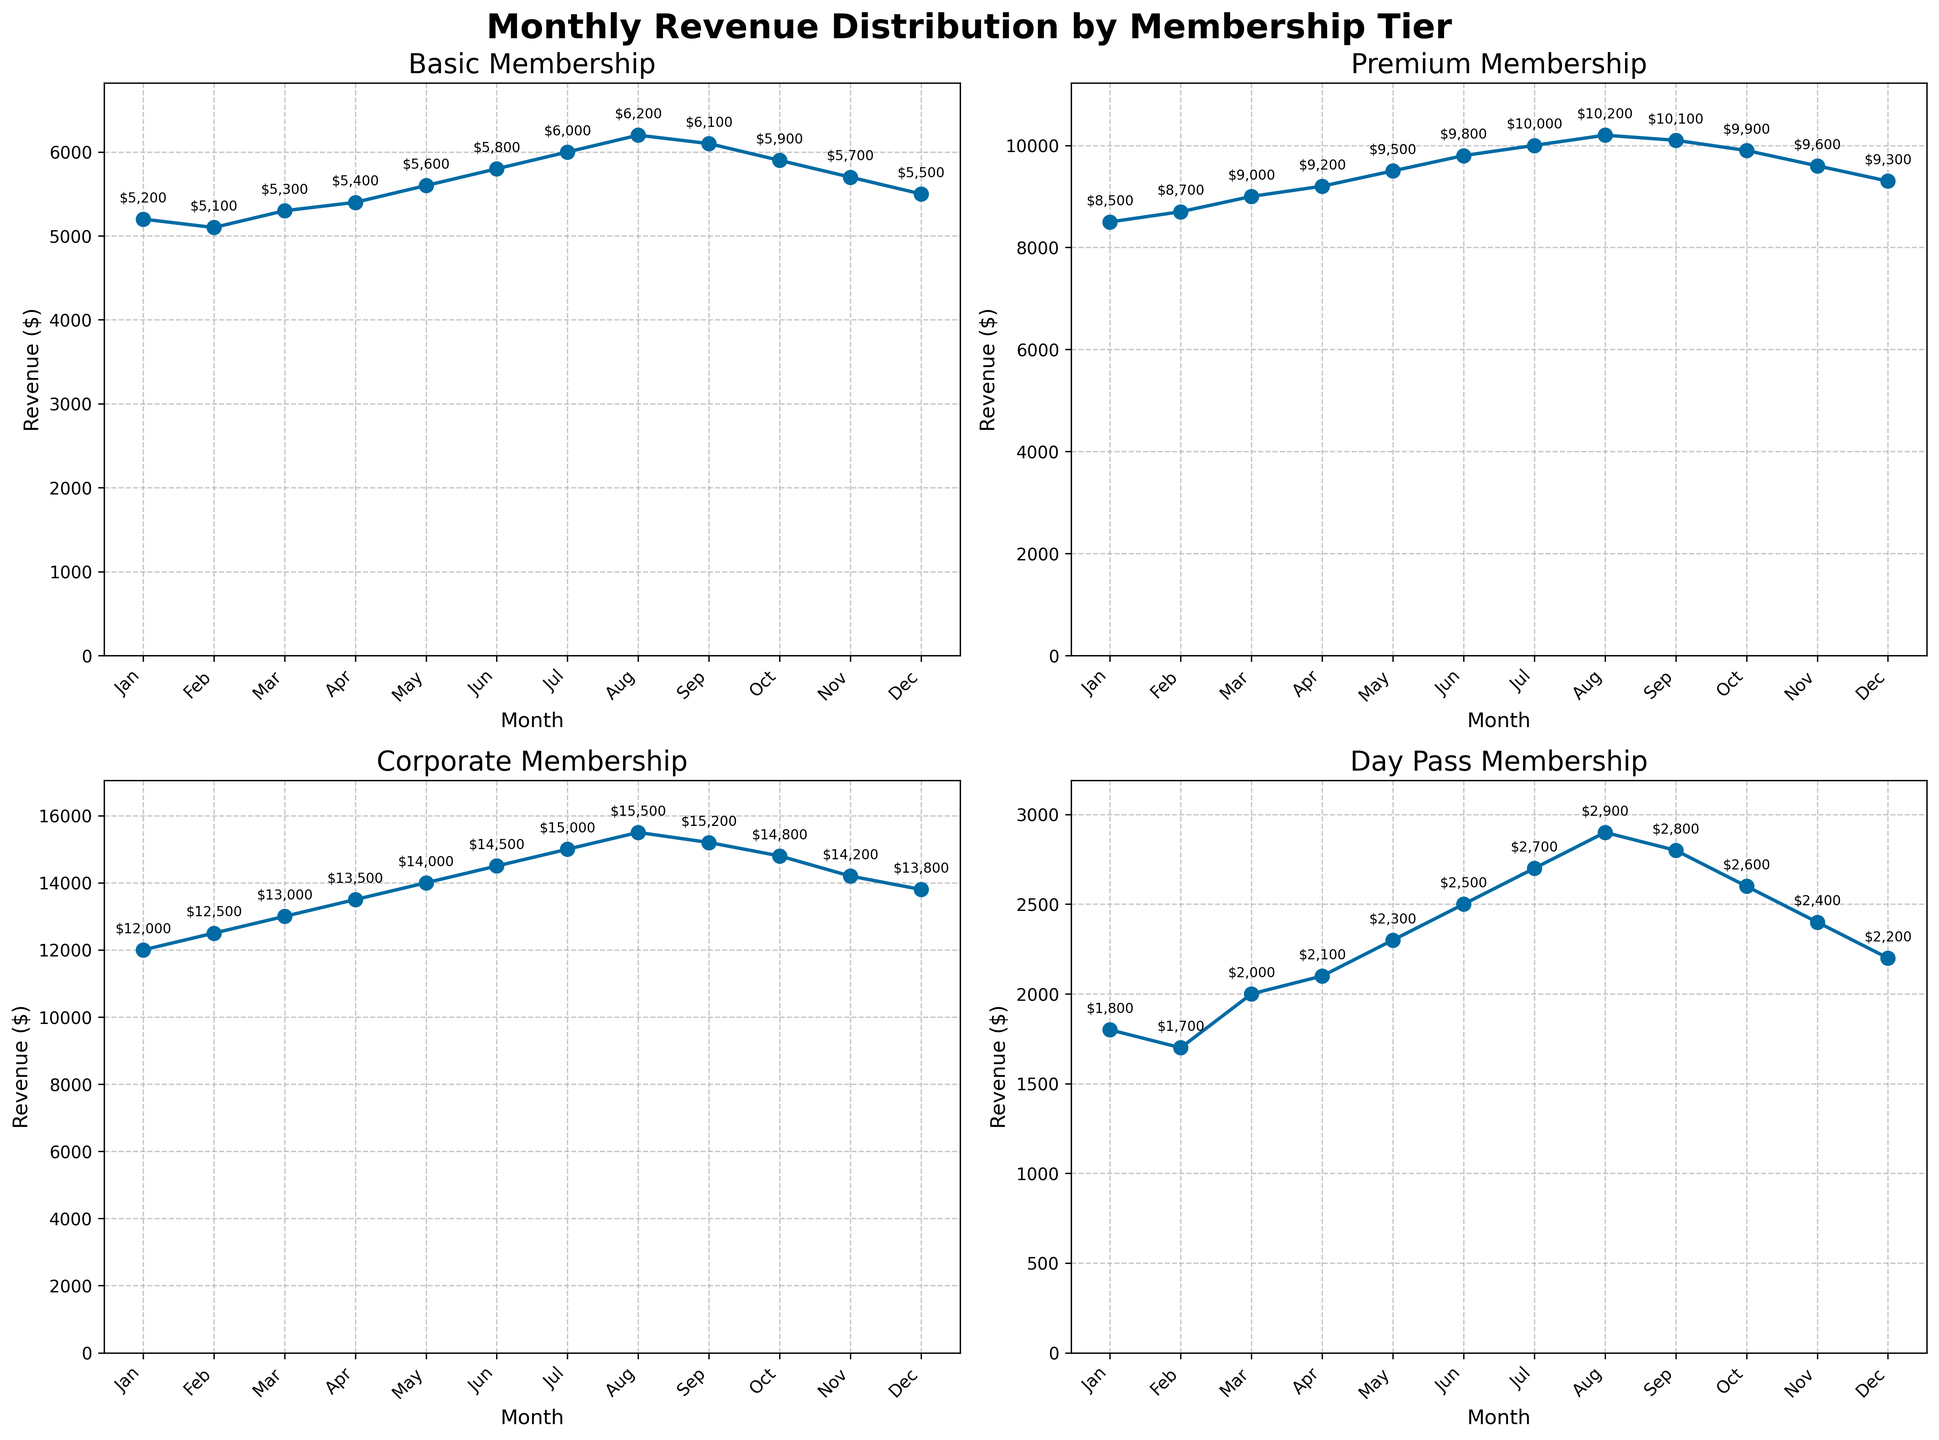What's the title of the overall figure? The title of the figure is located at the top and reads "Monthly Revenue Distribution by Membership Tier".
Answer: Monthly Revenue Distribution by Membership Tier What is the revenue for the Premium membership in June? To find this, look at the subplot for the Premium membership and locate the data point for June. The annotated value on this data point shows the revenue.
Answer: $9,800 Which membership tier had the lowest revenue in August? Look at each of the subplots for the month of August and compare the annotated revenue values. The Day Pass subplot shows the lowest revenue of $2,900.
Answer: Day Pass What trend do we observe for the Basic membership tier from January to December? Examine the line in the Basic membership subplot. It starts from around $5,200 in January and gradually increases to $6,200 in August before slightly decreasing to $5,500 in December.
Answer: Generally increasing How much higher was the revenue for the Corporate membership in March compared to February? The Corporate membership subplot shows $13,000 in March and $12,500 in February. The difference is $13,000 - $12,500.
Answer: $500 Which membership tier had the highest peak revenue, and in which month did it occur? Compare the peaks of all subplots. Corporate membership had the highest peak of $15,500 in August.
Answer: Corporate, August What is the average monthly revenue for Basic membership across the year? Sum all the monthly revenues for the Basic membership and then divide by the number of months (12). The annotated values are used for the sum: $5,200 + $5,100 + $5,300 + $5,400 + $5,600 + $5,800 + $6,000 + $6,200 + $6,100 + $5,900 + $5,700 + $5,500. The total is $67,800 and the average is $67,800 / 12.
Answer: $5,650 How does the trend for Premium membership compare from January to July? Observe the Premium membership subplot; the revenue increases steadily from $8,500 in January to $10,200 in August. This indicates a consistent upward trend.
Answer: Consistently increasing What is the maximum revenue recorded for Day Pass membership, and in which month did it occur? Look at the Day Pass subplot and find the highest annotated value, which is $2,900 in August.
Answer: $2,900, August What can you say about the revenue trend for Corporate membership in the last quarter (October to December)? Observe the Corporate membership subplot and see that the revenue decreases from $14,800 in October, to $14,200 in November, and then to $13,800 in December.
Answer: Decreasing 